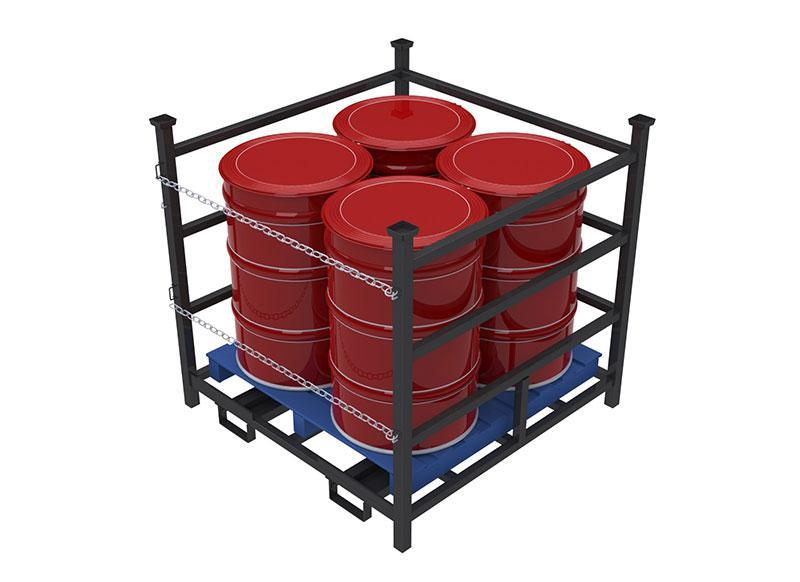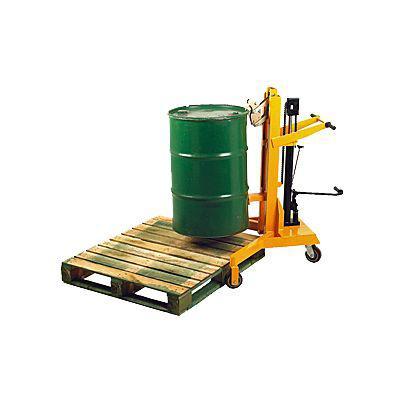The first image is the image on the left, the second image is the image on the right. Examine the images to the left and right. Is the description "Red barrels sit in a black metal fenced container with chains on one side in one of the images." accurate? Answer yes or no. Yes. The first image is the image on the left, the second image is the image on the right. For the images displayed, is the sentence "One image shows at least one cube-shaped black frame that contains four upright red barrels on a blue base." factually correct? Answer yes or no. Yes. 